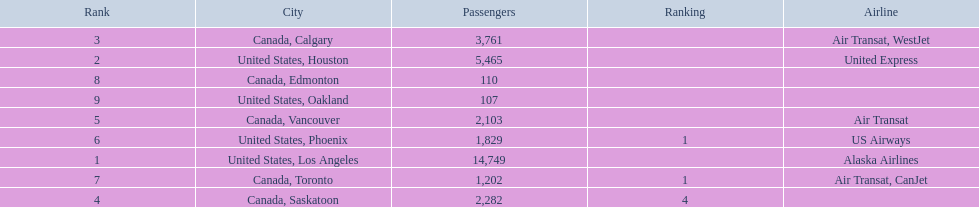What are the cities that are associated with the playa de oro international airport? United States, Los Angeles, United States, Houston, Canada, Calgary, Canada, Saskatoon, Canada, Vancouver, United States, Phoenix, Canada, Toronto, Canada, Edmonton, United States, Oakland. What is uniteed states, los angeles passenger count? 14,749. What other cities passenger count would lead to 19,000 roughly when combined with previous los angeles? Canada, Calgary. 